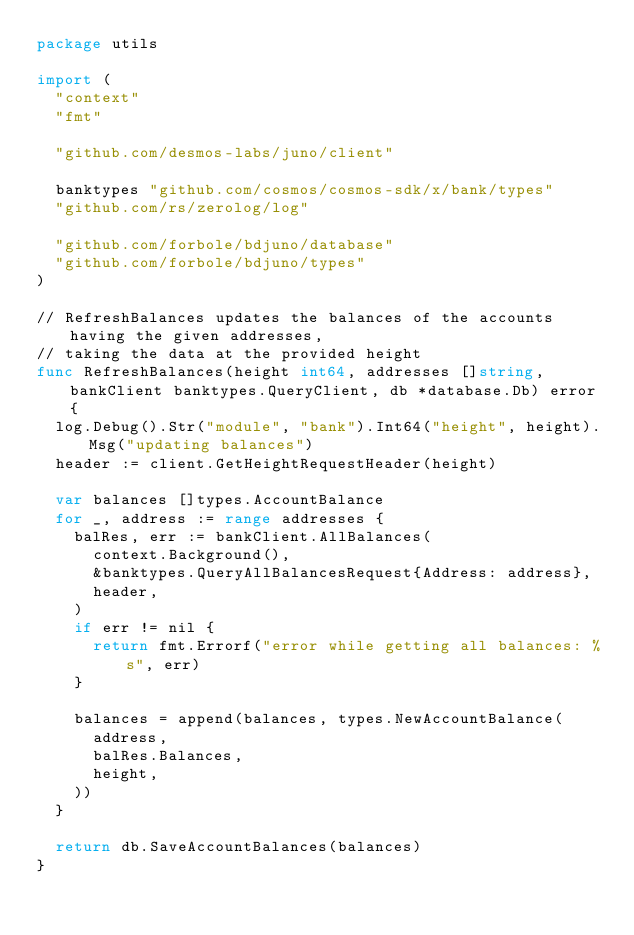Convert code to text. <code><loc_0><loc_0><loc_500><loc_500><_Go_>package utils

import (
	"context"
	"fmt"

	"github.com/desmos-labs/juno/client"

	banktypes "github.com/cosmos/cosmos-sdk/x/bank/types"
	"github.com/rs/zerolog/log"

	"github.com/forbole/bdjuno/database"
	"github.com/forbole/bdjuno/types"
)

// RefreshBalances updates the balances of the accounts having the given addresses,
// taking the data at the provided height
func RefreshBalances(height int64, addresses []string, bankClient banktypes.QueryClient, db *database.Db) error {
	log.Debug().Str("module", "bank").Int64("height", height).Msg("updating balances")
	header := client.GetHeightRequestHeader(height)

	var balances []types.AccountBalance
	for _, address := range addresses {
		balRes, err := bankClient.AllBalances(
			context.Background(),
			&banktypes.QueryAllBalancesRequest{Address: address},
			header,
		)
		if err != nil {
			return fmt.Errorf("error while getting all balances: %s", err)
		}

		balances = append(balances, types.NewAccountBalance(
			address,
			balRes.Balances,
			height,
		))
	}

	return db.SaveAccountBalances(balances)
}
</code> 